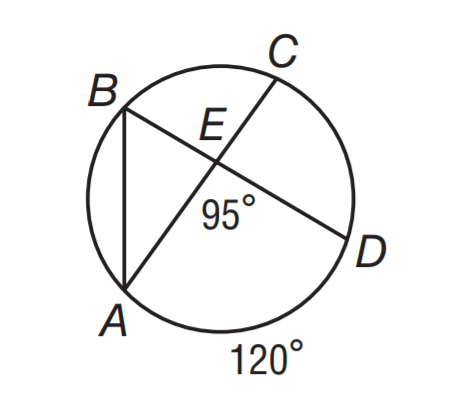Question: If m \angle A E D = 95 and m \widehat A D = 120, what is m \angle B A C?
Choices:
A. 30
B. 35
C. 40
D. 60
Answer with the letter. Answer: B 